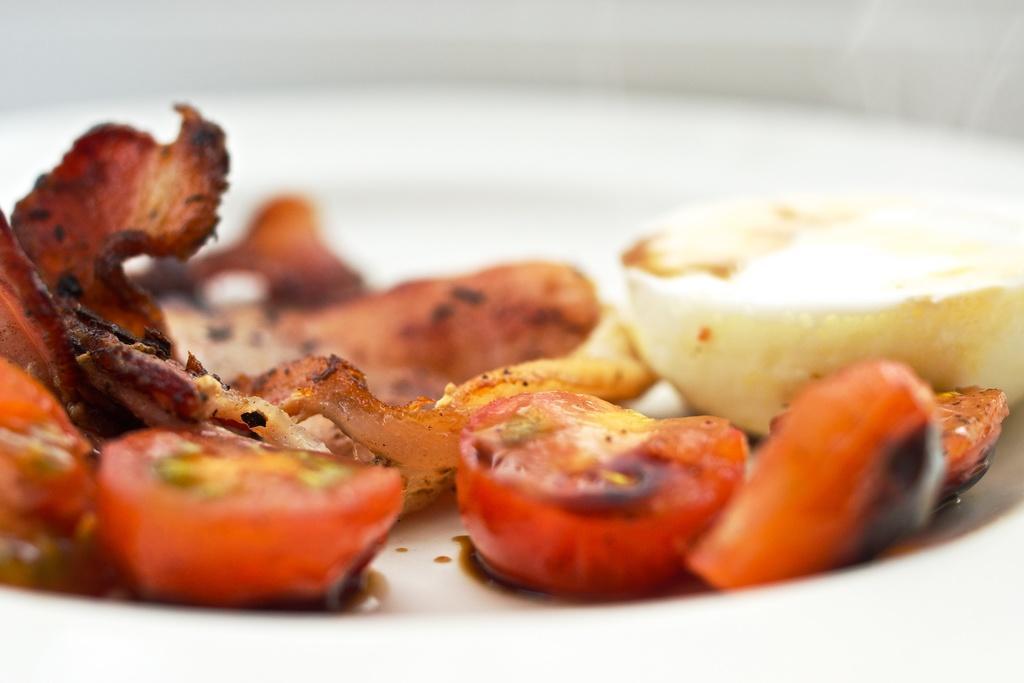Describe this image in one or two sentences. In this picture we can see some food item is placed in the plate. 